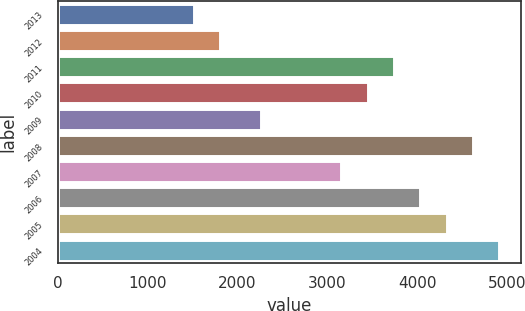<chart> <loc_0><loc_0><loc_500><loc_500><bar_chart><fcel>2013<fcel>2012<fcel>2011<fcel>2010<fcel>2009<fcel>2008<fcel>2007<fcel>2006<fcel>2005<fcel>2004<nl><fcel>1518<fcel>1811.1<fcel>3741.2<fcel>3448.1<fcel>2265<fcel>4620.5<fcel>3155<fcel>4034.3<fcel>4327.4<fcel>4913.6<nl></chart> 